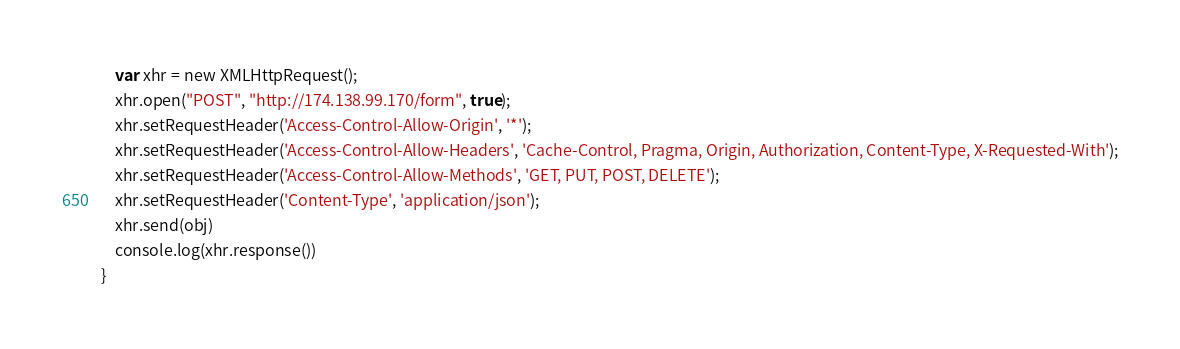<code> <loc_0><loc_0><loc_500><loc_500><_JavaScript_>    var xhr = new XMLHttpRequest();
    xhr.open("POST", "http://174.138.99.170/form", true);
    xhr.setRequestHeader('Access-Control-Allow-Origin', '*');
    xhr.setRequestHeader('Access-Control-Allow-Headers', 'Cache-Control, Pragma, Origin, Authorization, Content-Type, X-Requested-With');
    xhr.setRequestHeader('Access-Control-Allow-Methods', 'GET, PUT, POST, DELETE');
    xhr.setRequestHeader('Content-Type', 'application/json');
    xhr.send(obj)
    console.log(xhr.response())
}</code> 